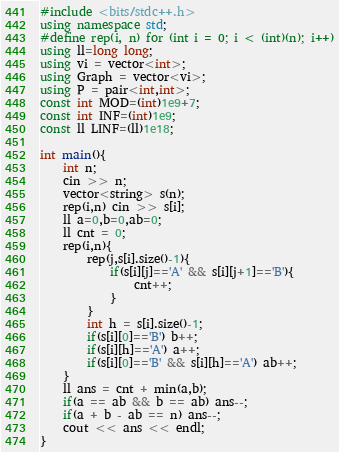<code> <loc_0><loc_0><loc_500><loc_500><_C++_>#include <bits/stdc++.h>
using namespace std;
#define rep(i, n) for (int i = 0; i < (int)(n); i++)
using ll=long long;
using vi = vector<int>;
using Graph = vector<vi>;
using P = pair<int,int>;
const int MOD=(int)1e9+7;
const int INF=(int)1e9;
const ll LINF=(ll)1e18;

int main(){
    int n;
    cin >> n;
    vector<string> s(n);
    rep(i,n) cin >> s[i];
    ll a=0,b=0,ab=0;
    ll cnt = 0;
    rep(i,n){
        rep(j,s[i].size()-1){
            if(s[i][j]=='A' && s[i][j+1]=='B'){
                cnt++;
            }
        }
        int h = s[i].size()-1;
        if(s[i][0]=='B') b++;
        if(s[i][h]=='A') a++;
        if(s[i][0]=='B' && s[i][h]=='A') ab++;
    }
    ll ans = cnt + min(a,b);
    if(a == ab && b == ab) ans--;  
    if(a + b - ab == n) ans--;
    cout << ans << endl;
}</code> 